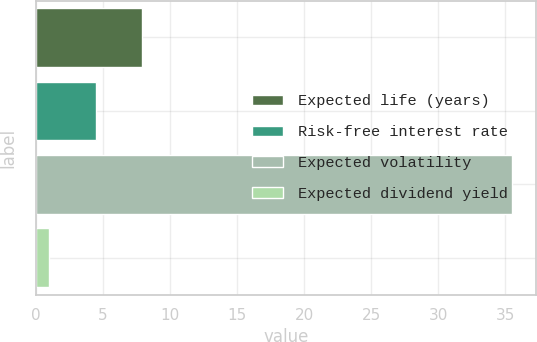Convert chart. <chart><loc_0><loc_0><loc_500><loc_500><bar_chart><fcel>Expected life (years)<fcel>Risk-free interest rate<fcel>Expected volatility<fcel>Expected dividend yield<nl><fcel>7.9<fcel>4.45<fcel>35.5<fcel>1<nl></chart> 